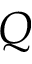Convert formula to latex. <formula><loc_0><loc_0><loc_500><loc_500>Q</formula> 